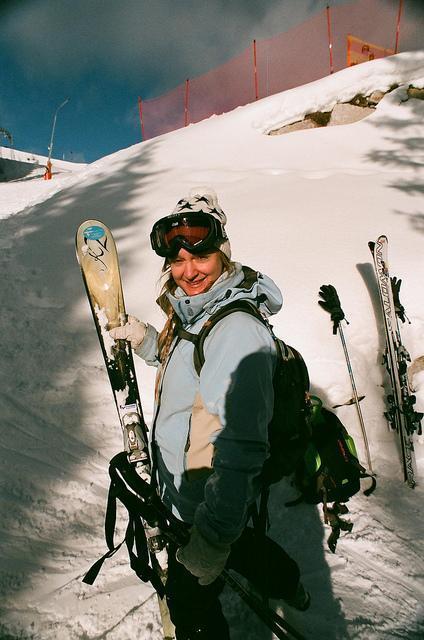How many ski are there?
Give a very brief answer. 2. 